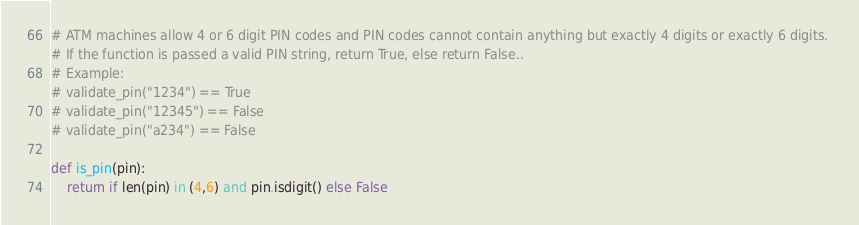<code> <loc_0><loc_0><loc_500><loc_500><_Python_># ATM machines allow 4 or 6 digit PIN codes and PIN codes cannot contain anything but exactly 4 digits or exactly 6 digits. 
# If the function is passed a valid PIN string, return True, else return False..
# Example:
# validate_pin("1234") == True
# validate_pin("12345") == False
# validate_pin("a234") == False

def is_pin(pin):
    return if len(pin) in (4,6) and pin.isdigit() else False
</code> 